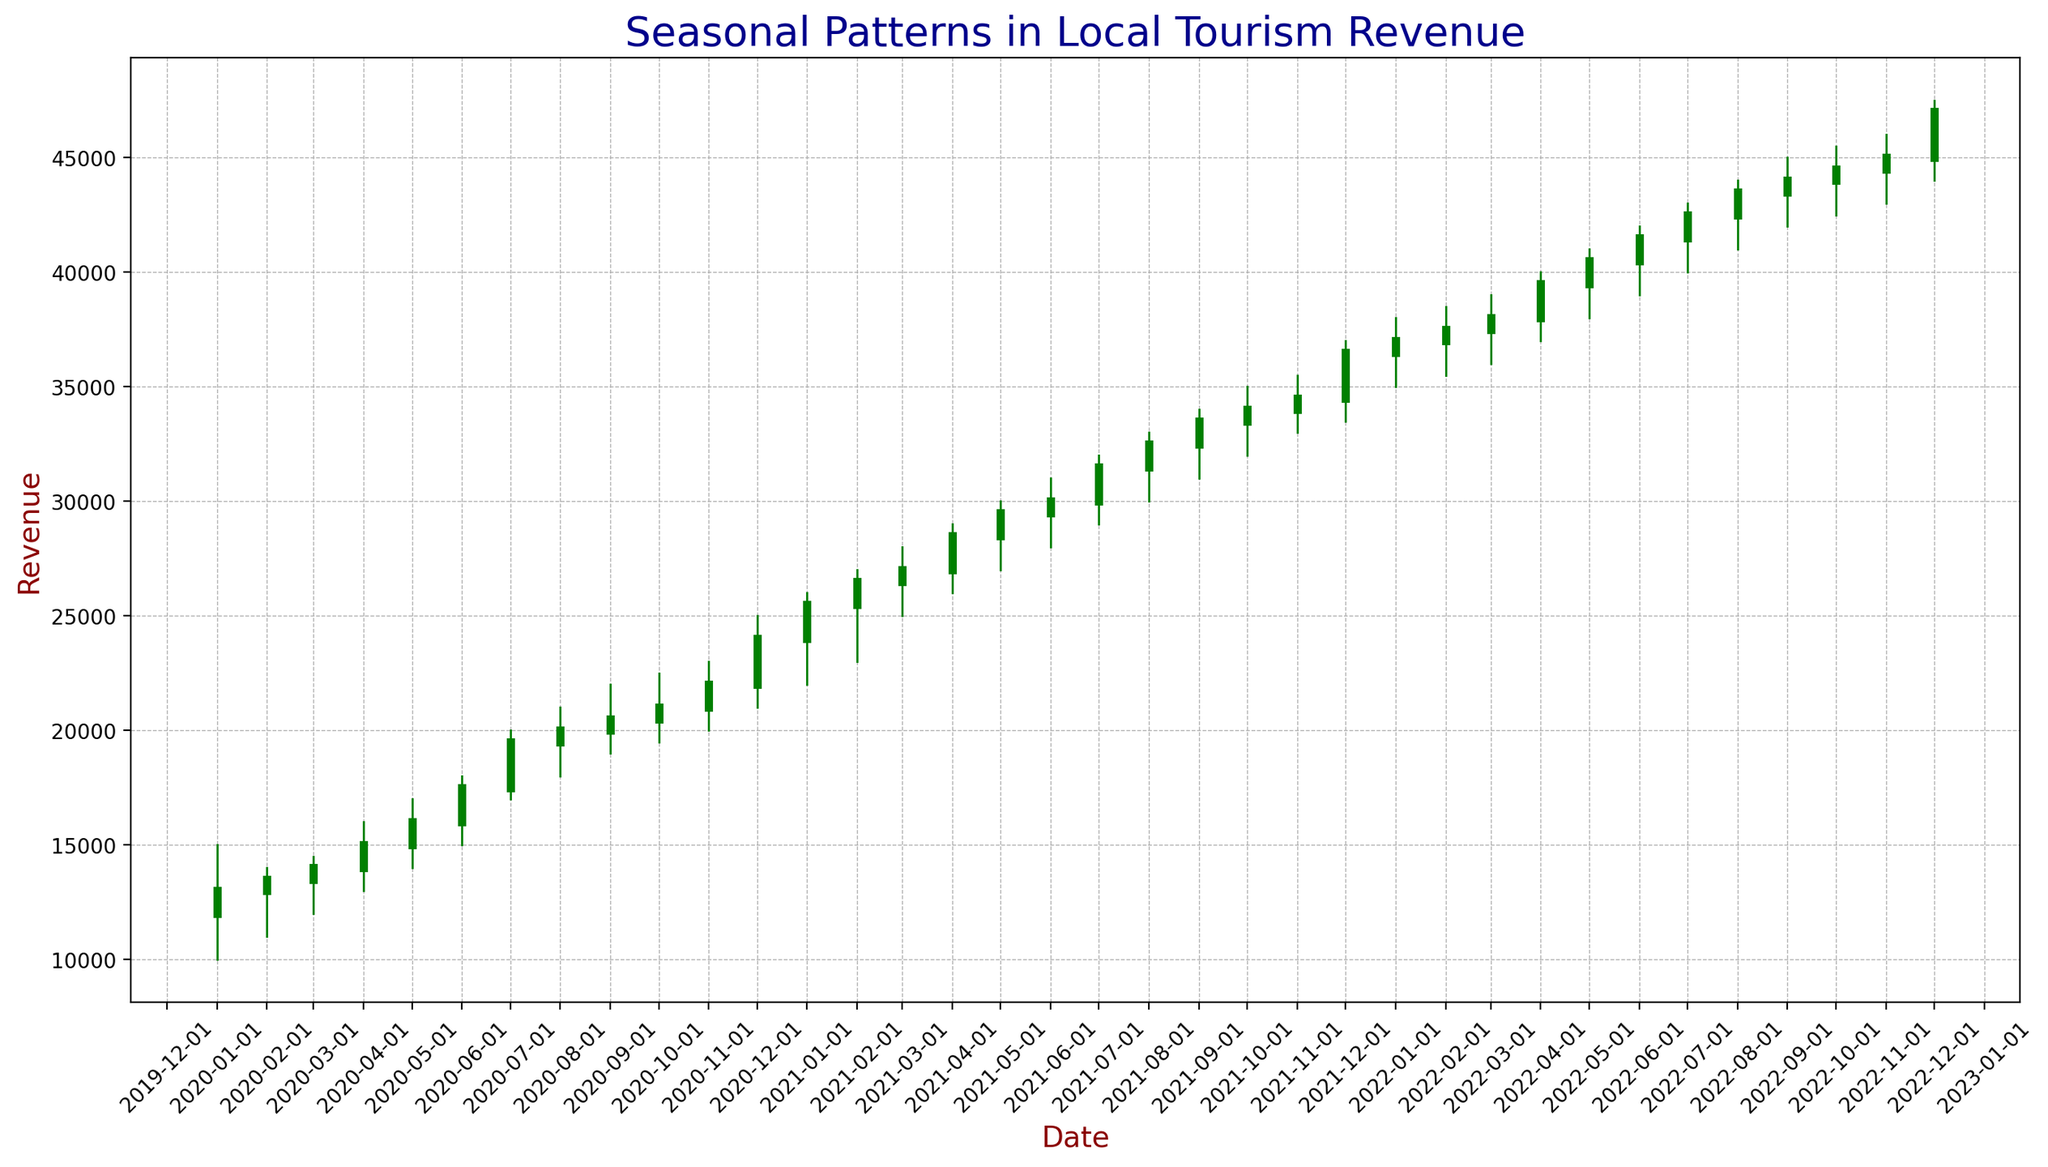When do we start observing an increase in local tourism revenue in 2020? To determine when the increase begins, look at the candlestick bars from the start of 2020. Noticeable increases appear from April, where the closing value exceeds the previous month's closing value significantly.
Answer: April 2020 During which months in 2020 did the local tourism revenue decrease? To identify decreasing months, focus on the red candlestick bars which indicate a decline. There are visible decreases in November 2020.
Answer: November 2020 How does the tourism revenue in December 2021 compare to December 2022? Which one is higher? Compare the closing values at the end of December 2021 and December 2022. The closing value in December 2021 is 36,500, and in December 2022 is 47,000. Thus, December 2022 is higher.
Answer: December 2022 What is the trend in local tourism revenue from January 2022 to December 2022? To observe the trend, look at all the candlestick bars from January 2022 to December 2022. The bars show a general upward trend indicated by increasing closing values throughout the year.
Answer: Upward trend During which month in 2021 was the biggest increase in tourism revenue observed compared to the previous month? To find the biggest increase, check the month-to-month increase in closing values for 2021. The largest increase is between February 2021 (26,500) and March 2021 (27,000), where the difference is 1,500.
Answer: February to March 2021 What is the average closing revenue for the months of June, July, and August in 2022? Sum the closing values for June (41,500), July (42,500), and August (43,500) and divide by 3: (41,500 + 42,500 + 43,500)/3 = 42,500.
Answer: 42,500 Is the local tourism revenue showing any seasonal patterns? If so, what are they? Seasonal patterns can be identified by recognizing repetitive trends across years for the same months. Revenues generally peak around July-August and decrease around November-December, showing consistent seasonal patterns.
Answer: Peaking in July-August, decreasing in November-December What was the highest closing value observed in the entire period, and in which month and year did it occur? Identify the highest closing value by scanning the chart. The highest value is 47,000, which occurred in December 2022.
Answer: December 2022 Compare the local tourism revenue in January over the three years. What trend do you observe? Compare the closing values for January in 2020 (13,000), 2021 (25,500), and 2022 (37,000). The revenue shows a consistent increase each year.
Answer: Increasing trend What is the difference between the highest and lowest closing values in the entire period? The highest closing value is 47,000 (Dec 2022), and the lowest is 13,000 (Jan 2020). The difference is calculated as 47,000 - 13,000 = 34,000.
Answer: 34,000 